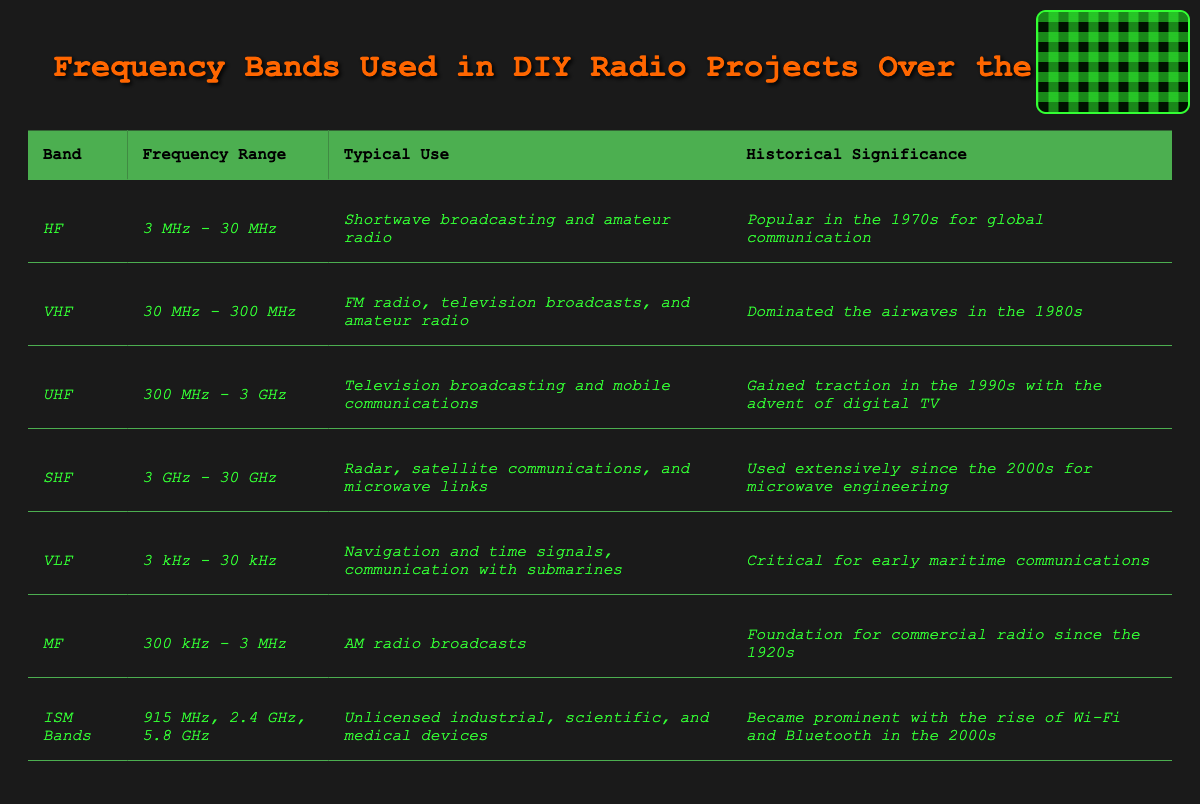What is the frequency range of VHF? In the table, the frequency range for VHF is clearly stated as 30 MHz - 300 MHz.
Answer: 30 MHz - 300 MHz Which frequency band is used for AM radio broadcasts? By looking at the table, it shows that MF is used for AM radio broadcasts.
Answer: MF What is the historical significance of HF? The table indicates that HF was popular in the 1970s for global communication.
Answer: Popular in the 1970s for global communication Which frequency bands have a typical use in amateur radio? The table lists HF, VHF, and MF as having a typical use in amateur radio.
Answer: HF, VHF, and MF What is the difference in frequency ranges between VHF and UHF? VHF ranges from 30 MHz to 300 MHz, while UHF ranges from 300 MHz to 3 GHz. The difference is 300 MHz - 30 MHz = 270 MHz for VHF and 3 GHz - 300 MHz = 2.7 GHz for UHF, showing UHF spans a wider range.
Answer: 2.7 GHz Is it true that the ISM bands became prominent with the rise of Wi-Fi and Bluetooth in the 2000s? According to the table, the ISM bands did gain prominence with the rise of Wi-Fi and Bluetooth in the 2000s which confirms the statement as true.
Answer: Yes Which band has the narrowest frequency range? The table shows that VLF has the narrowest frequency range of 3 kHz - 30 kHz compared to others which are wider.
Answer: VLF How many frequency bands are associated with television broadcasting? The table indicates that VHF and UHF are both associated with television broadcasting.
Answer: 2 What was the foundation for commercial radio since the 1920s? The table states that MF was the foundation for commercial radio since the 1920s.
Answer: MF Which band is used primarily for navigation and time signals? From the table, VLF is identified as being primarily used for navigation and time signals.
Answer: VLF What is the range of the SHF band, and what is its typical use? The table lists the SHF band as 3 GHz - 30 GHz, typically used for radar, satellite communications, and microwave links. Therefore, the range is 3 GHz - 30 GHz with the specified uses.
Answer: 3 GHz - 30 GHz; Radar, satellite communications, microwave links 